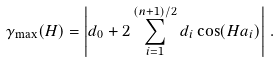<formula> <loc_0><loc_0><loc_500><loc_500>\gamma _ { \max } ( H ) = \left | d _ { 0 } + 2 \sum _ { i = 1 } ^ { ( n + 1 ) / 2 } d _ { i } \cos ( H a _ { i } ) \right | \, .</formula> 